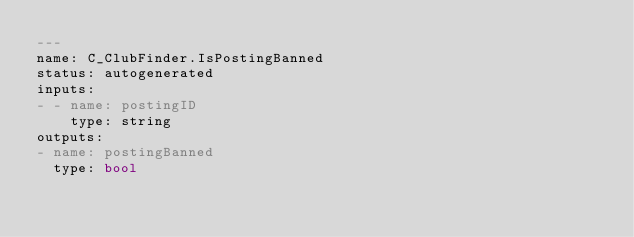Convert code to text. <code><loc_0><loc_0><loc_500><loc_500><_YAML_>---
name: C_ClubFinder.IsPostingBanned
status: autogenerated
inputs:
- - name: postingID
    type: string
outputs:
- name: postingBanned
  type: bool
</code> 